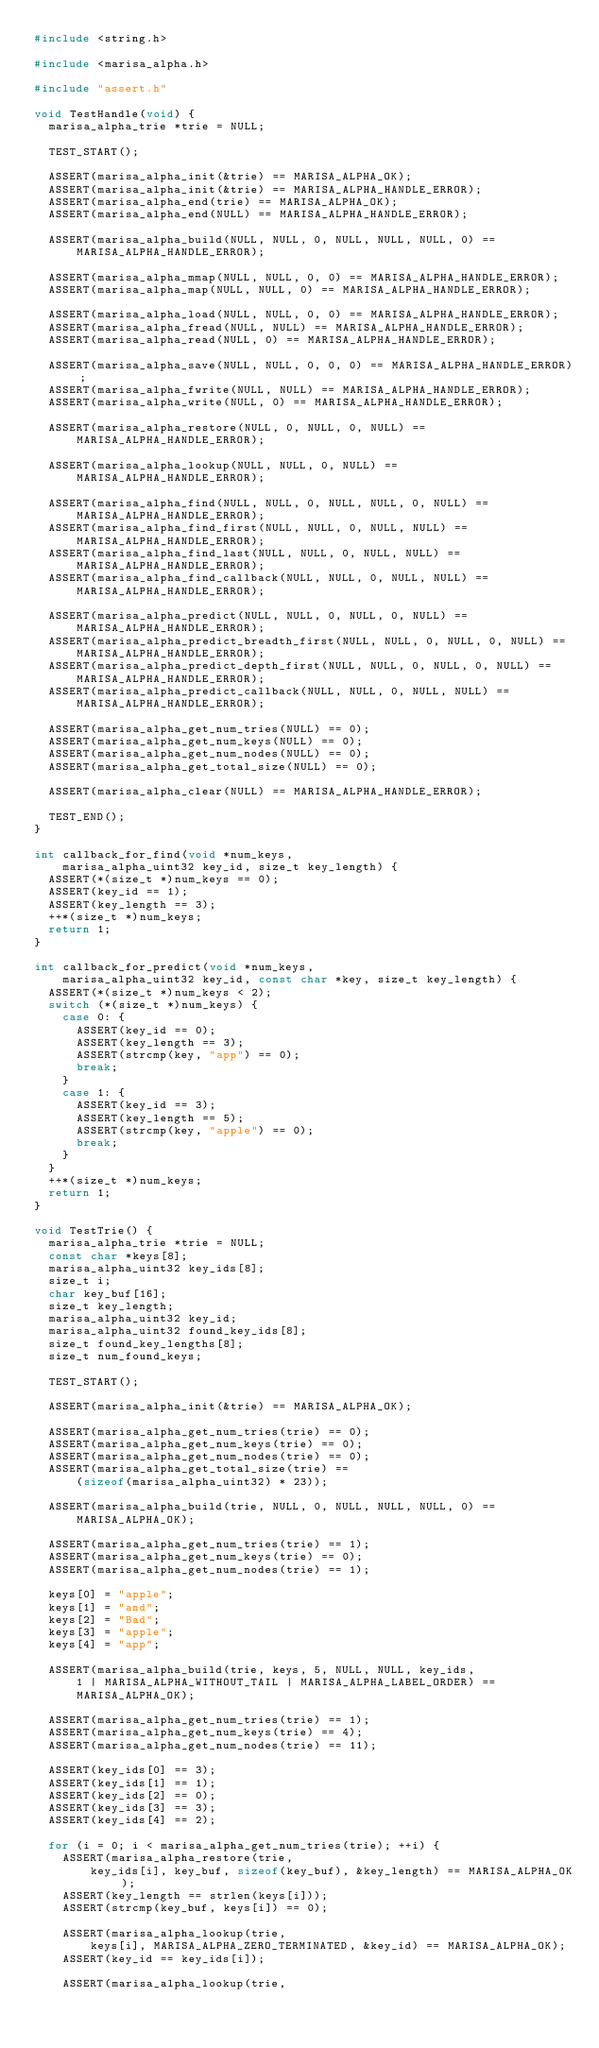Convert code to text. <code><loc_0><loc_0><loc_500><loc_500><_C_>#include <string.h>

#include <marisa_alpha.h>

#include "assert.h"

void TestHandle(void) {
  marisa_alpha_trie *trie = NULL;

  TEST_START();

  ASSERT(marisa_alpha_init(&trie) == MARISA_ALPHA_OK);
  ASSERT(marisa_alpha_init(&trie) == MARISA_ALPHA_HANDLE_ERROR);
  ASSERT(marisa_alpha_end(trie) == MARISA_ALPHA_OK);
  ASSERT(marisa_alpha_end(NULL) == MARISA_ALPHA_HANDLE_ERROR);

  ASSERT(marisa_alpha_build(NULL, NULL, 0, NULL, NULL, NULL, 0) ==
      MARISA_ALPHA_HANDLE_ERROR);

  ASSERT(marisa_alpha_mmap(NULL, NULL, 0, 0) == MARISA_ALPHA_HANDLE_ERROR);
  ASSERT(marisa_alpha_map(NULL, NULL, 0) == MARISA_ALPHA_HANDLE_ERROR);

  ASSERT(marisa_alpha_load(NULL, NULL, 0, 0) == MARISA_ALPHA_HANDLE_ERROR);
  ASSERT(marisa_alpha_fread(NULL, NULL) == MARISA_ALPHA_HANDLE_ERROR);
  ASSERT(marisa_alpha_read(NULL, 0) == MARISA_ALPHA_HANDLE_ERROR);

  ASSERT(marisa_alpha_save(NULL, NULL, 0, 0, 0) == MARISA_ALPHA_HANDLE_ERROR);
  ASSERT(marisa_alpha_fwrite(NULL, NULL) == MARISA_ALPHA_HANDLE_ERROR);
  ASSERT(marisa_alpha_write(NULL, 0) == MARISA_ALPHA_HANDLE_ERROR);

  ASSERT(marisa_alpha_restore(NULL, 0, NULL, 0, NULL) ==
      MARISA_ALPHA_HANDLE_ERROR);

  ASSERT(marisa_alpha_lookup(NULL, NULL, 0, NULL) ==
      MARISA_ALPHA_HANDLE_ERROR);

  ASSERT(marisa_alpha_find(NULL, NULL, 0, NULL, NULL, 0, NULL) ==
      MARISA_ALPHA_HANDLE_ERROR);
  ASSERT(marisa_alpha_find_first(NULL, NULL, 0, NULL, NULL) ==
      MARISA_ALPHA_HANDLE_ERROR);
  ASSERT(marisa_alpha_find_last(NULL, NULL, 0, NULL, NULL) ==
      MARISA_ALPHA_HANDLE_ERROR);
  ASSERT(marisa_alpha_find_callback(NULL, NULL, 0, NULL, NULL) ==
      MARISA_ALPHA_HANDLE_ERROR);

  ASSERT(marisa_alpha_predict(NULL, NULL, 0, NULL, 0, NULL) ==
      MARISA_ALPHA_HANDLE_ERROR);
  ASSERT(marisa_alpha_predict_breadth_first(NULL, NULL, 0, NULL, 0, NULL) ==
      MARISA_ALPHA_HANDLE_ERROR);
  ASSERT(marisa_alpha_predict_depth_first(NULL, NULL, 0, NULL, 0, NULL) ==
      MARISA_ALPHA_HANDLE_ERROR);
  ASSERT(marisa_alpha_predict_callback(NULL, NULL, 0, NULL, NULL) ==
      MARISA_ALPHA_HANDLE_ERROR);

  ASSERT(marisa_alpha_get_num_tries(NULL) == 0);
  ASSERT(marisa_alpha_get_num_keys(NULL) == 0);
  ASSERT(marisa_alpha_get_num_nodes(NULL) == 0);
  ASSERT(marisa_alpha_get_total_size(NULL) == 0);

  ASSERT(marisa_alpha_clear(NULL) == MARISA_ALPHA_HANDLE_ERROR);

  TEST_END();
}

int callback_for_find(void *num_keys,
    marisa_alpha_uint32 key_id, size_t key_length) {
  ASSERT(*(size_t *)num_keys == 0);
  ASSERT(key_id == 1);
  ASSERT(key_length == 3);
  ++*(size_t *)num_keys;
  return 1;
}

int callback_for_predict(void *num_keys,
    marisa_alpha_uint32 key_id, const char *key, size_t key_length) {
  ASSERT(*(size_t *)num_keys < 2);
  switch (*(size_t *)num_keys) {
    case 0: {
      ASSERT(key_id == 0);
      ASSERT(key_length == 3);
      ASSERT(strcmp(key, "app") == 0);
      break;
    }
    case 1: {
      ASSERT(key_id == 3);
      ASSERT(key_length == 5);
      ASSERT(strcmp(key, "apple") == 0);
      break;
    }
  }
  ++*(size_t *)num_keys;
  return 1;
}

void TestTrie() {
  marisa_alpha_trie *trie = NULL;
  const char *keys[8];
  marisa_alpha_uint32 key_ids[8];
  size_t i;
  char key_buf[16];
  size_t key_length;
  marisa_alpha_uint32 key_id;
  marisa_alpha_uint32 found_key_ids[8];
  size_t found_key_lengths[8];
  size_t num_found_keys;

  TEST_START();

  ASSERT(marisa_alpha_init(&trie) == MARISA_ALPHA_OK);

  ASSERT(marisa_alpha_get_num_tries(trie) == 0);
  ASSERT(marisa_alpha_get_num_keys(trie) == 0);
  ASSERT(marisa_alpha_get_num_nodes(trie) == 0);
  ASSERT(marisa_alpha_get_total_size(trie) ==
      (sizeof(marisa_alpha_uint32) * 23));

  ASSERT(marisa_alpha_build(trie, NULL, 0, NULL, NULL, NULL, 0) ==
      MARISA_ALPHA_OK);

  ASSERT(marisa_alpha_get_num_tries(trie) == 1);
  ASSERT(marisa_alpha_get_num_keys(trie) == 0);
  ASSERT(marisa_alpha_get_num_nodes(trie) == 1);

  keys[0] = "apple";
  keys[1] = "and";
  keys[2] = "Bad";
  keys[3] = "apple";
  keys[4] = "app";

  ASSERT(marisa_alpha_build(trie, keys, 5, NULL, NULL, key_ids,
      1 | MARISA_ALPHA_WITHOUT_TAIL | MARISA_ALPHA_LABEL_ORDER) ==
      MARISA_ALPHA_OK);

  ASSERT(marisa_alpha_get_num_tries(trie) == 1);
  ASSERT(marisa_alpha_get_num_keys(trie) == 4);
  ASSERT(marisa_alpha_get_num_nodes(trie) == 11);

  ASSERT(key_ids[0] == 3);
  ASSERT(key_ids[1] == 1);
  ASSERT(key_ids[2] == 0);
  ASSERT(key_ids[3] == 3);
  ASSERT(key_ids[4] == 2);

  for (i = 0; i < marisa_alpha_get_num_tries(trie); ++i) {
    ASSERT(marisa_alpha_restore(trie,
        key_ids[i], key_buf, sizeof(key_buf), &key_length) == MARISA_ALPHA_OK);
    ASSERT(key_length == strlen(keys[i]));
    ASSERT(strcmp(key_buf, keys[i]) == 0);

    ASSERT(marisa_alpha_lookup(trie,
        keys[i], MARISA_ALPHA_ZERO_TERMINATED, &key_id) == MARISA_ALPHA_OK);
    ASSERT(key_id == key_ids[i]);

    ASSERT(marisa_alpha_lookup(trie,</code> 